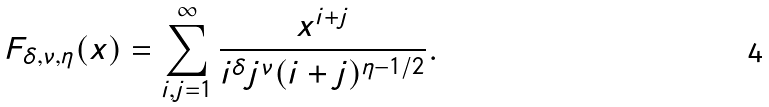Convert formula to latex. <formula><loc_0><loc_0><loc_500><loc_500>F _ { \delta , \nu , \eta } ( x ) = \sum _ { i , j = 1 } ^ { \infty } \frac { x ^ { i + j } } { i ^ { \delta } j ^ { \nu } ( i + j ) ^ { \eta - 1 / 2 } } .</formula> 